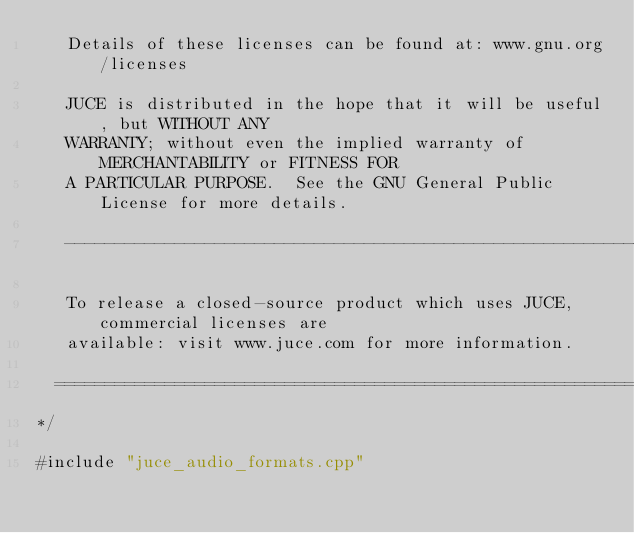<code> <loc_0><loc_0><loc_500><loc_500><_ObjectiveC_>   Details of these licenses can be found at: www.gnu.org/licenses

   JUCE is distributed in the hope that it will be useful, but WITHOUT ANY
   WARRANTY; without even the implied warranty of MERCHANTABILITY or FITNESS FOR
   A PARTICULAR PURPOSE.  See the GNU General Public License for more details.

   ------------------------------------------------------------------------------

   To release a closed-source product which uses JUCE, commercial licenses are
   available: visit www.juce.com for more information.

  ==============================================================================
*/

#include "juce_audio_formats.cpp"
</code> 